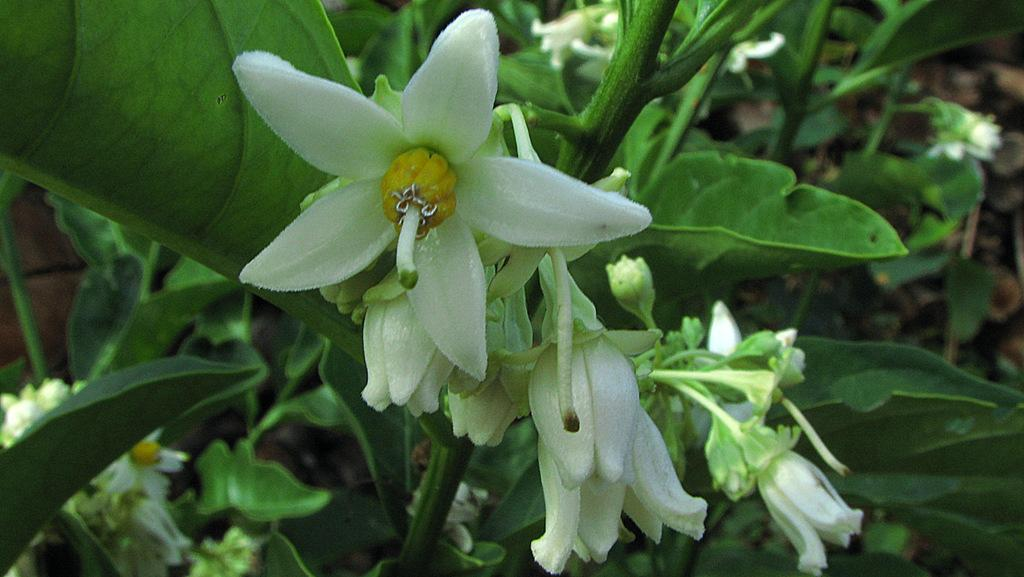What type of flowers can be seen on the plants in the image? There are white flowers on the plants in the image. How many flies are sitting on the furniture in the image? There is no furniture or flies present in the image; it only features plants with white flowers. 